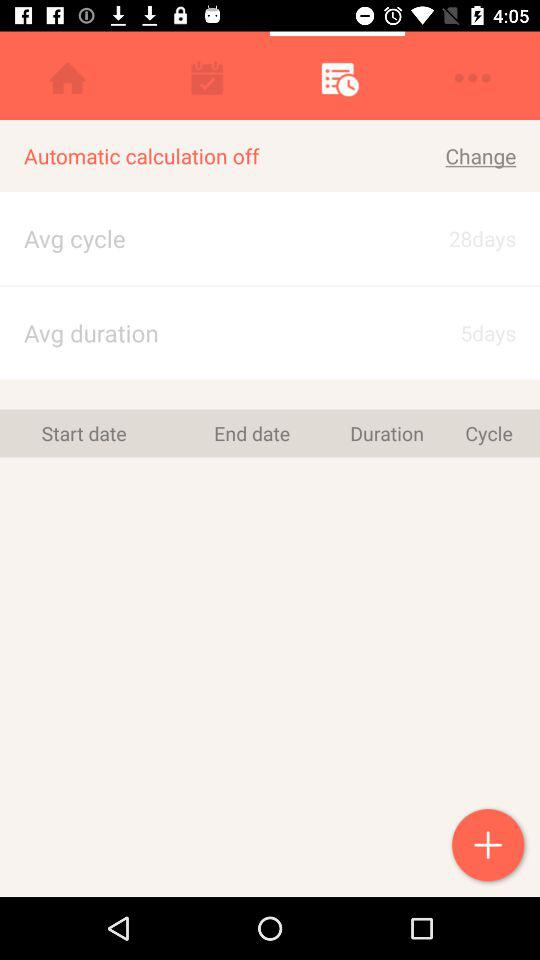What is the mentioned average duration? The mentioned average duration is 5 days. 